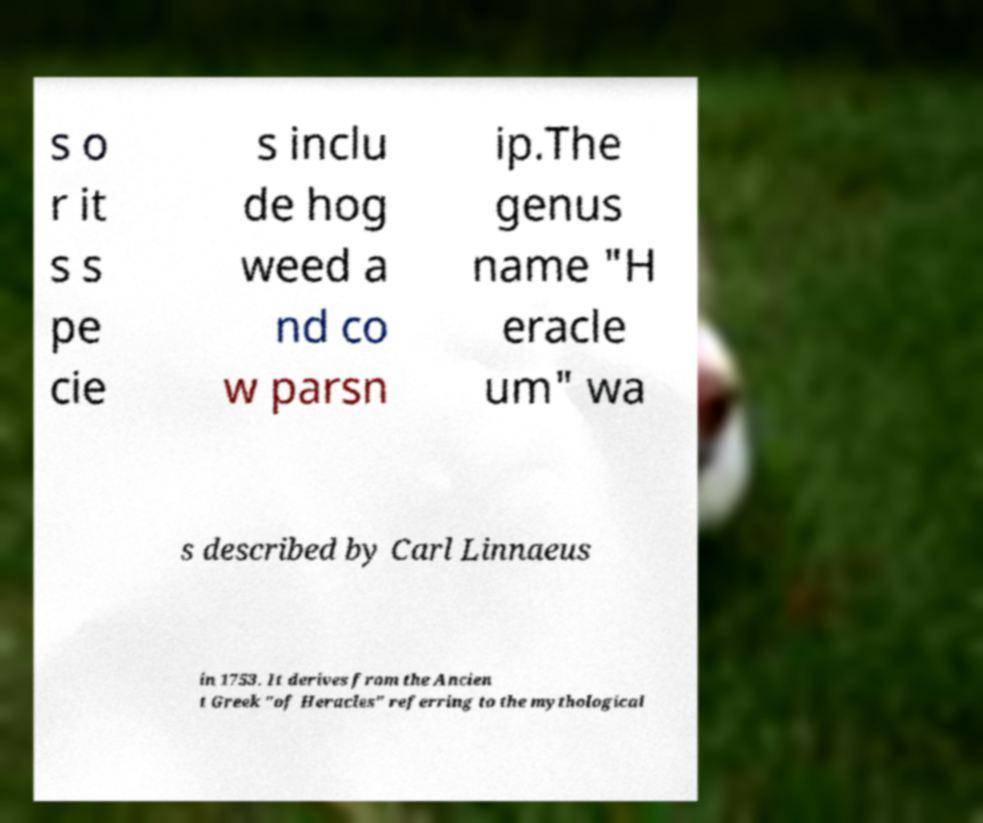Could you extract and type out the text from this image? s o r it s s pe cie s inclu de hog weed a nd co w parsn ip.The genus name "H eracle um" wa s described by Carl Linnaeus in 1753. It derives from the Ancien t Greek "of Heracles" referring to the mythological 